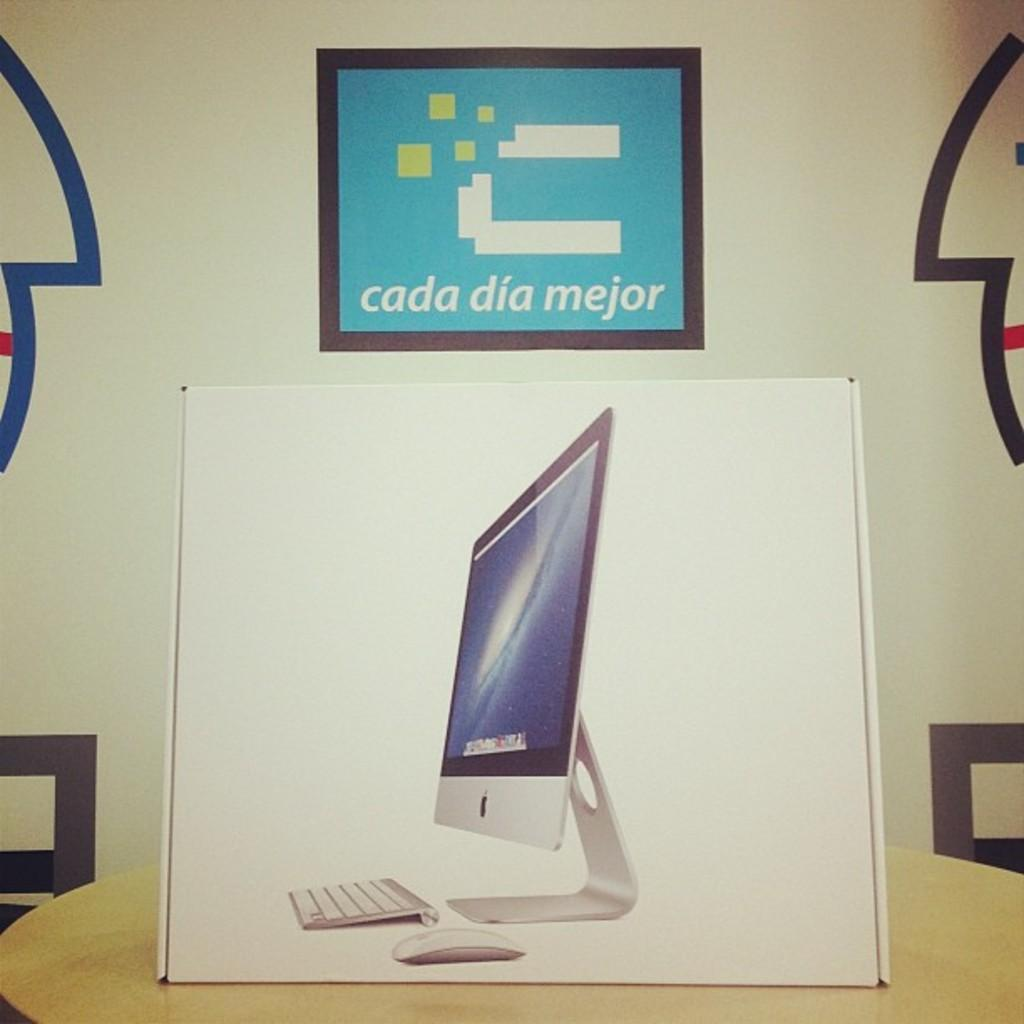<image>
Relay a brief, clear account of the picture shown. Box of an Apple product under a sign that says "cada dia mejor". 